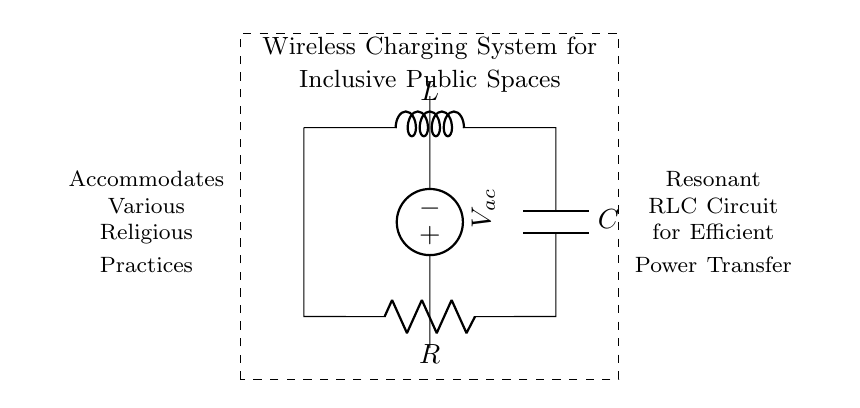What type of circuit is this? This is a resonant RLC circuit, which consists of a resistor, inductor, and capacitor arranged to create resonance. The diagram specifically indicates the presence of these three components arranged in a loop.
Answer: RLC circuit What are the components in the circuit? The components visible in the circuit include an inductor (L), a capacitor (C), and a resistor (R). Each component is labeled distinctly in the diagram, making their identification straightforward.
Answer: Inductor, capacitor, resistor What does the dashed rectangle represent? The dashed rectangle encompasses the entire circuit, indicating the boundaries of the wireless charging system. It visually separates the circuit from additional descriptive information written around it, signifying the scope of the system.
Answer: Wireless charging system What is the function of the voltage source in this circuit? The voltage source provides alternating current (ac), which is needed for the RLC circuit to operate effectively and resonates at a specific frequency, allowing for efficient energy transfer in wireless charging applications.
Answer: Alternating current How does the resonant frequency relate to this circuit? The resonant frequency is determined by the values of the resistor, inductor, and capacitor in the circuit. At this frequency, the circuit can achieve maximum power transfer, which is essential for efficient wireless charging in public spaces. The resonant frequency can be calculated using the formula \( f = \frac{1}{2\pi\sqrt{LC}} \), where L is the inductance and C is the capacitance.
Answer: Maximum power transfer 